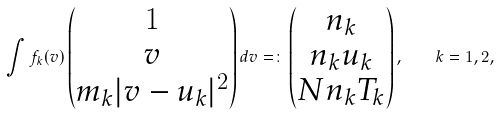<formula> <loc_0><loc_0><loc_500><loc_500>\int f _ { k } ( v ) \begin{pmatrix} 1 \\ v \\ m _ { k } | v - u _ { k } | ^ { 2 } \end{pmatrix} d v = \colon \begin{pmatrix} n _ { k } \\ n _ { k } u _ { k } \\ N n _ { k } T _ { k } \end{pmatrix} , \quad k = 1 , 2 ,</formula> 